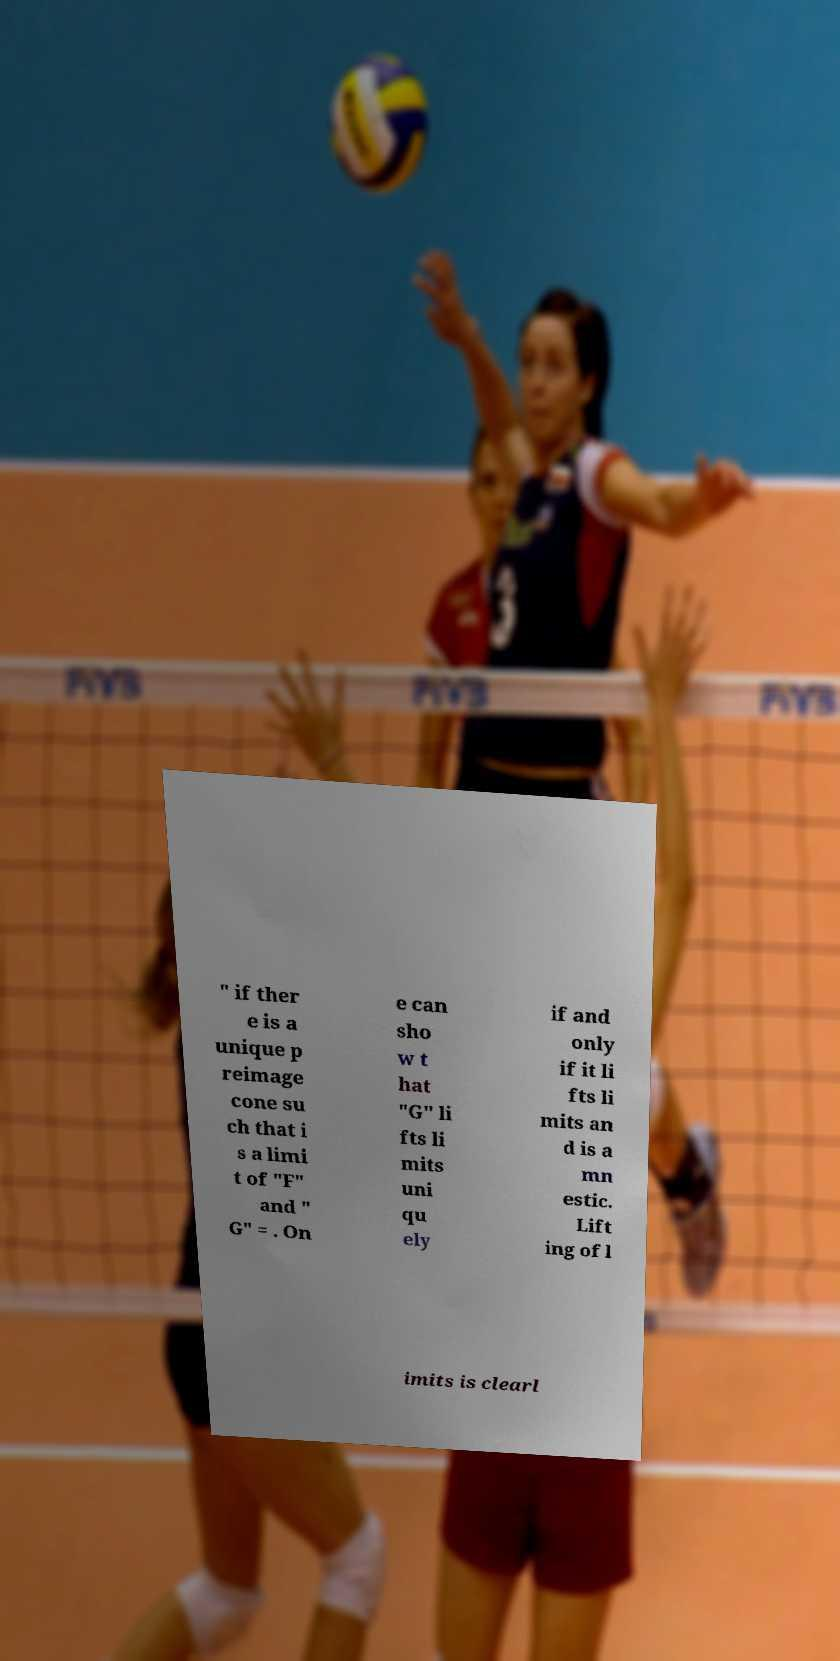I need the written content from this picture converted into text. Can you do that? " if ther e is a unique p reimage cone su ch that i s a limi t of "F" and " G" = . On e can sho w t hat "G" li fts li mits uni qu ely if and only if it li fts li mits an d is a mn estic. Lift ing of l imits is clearl 